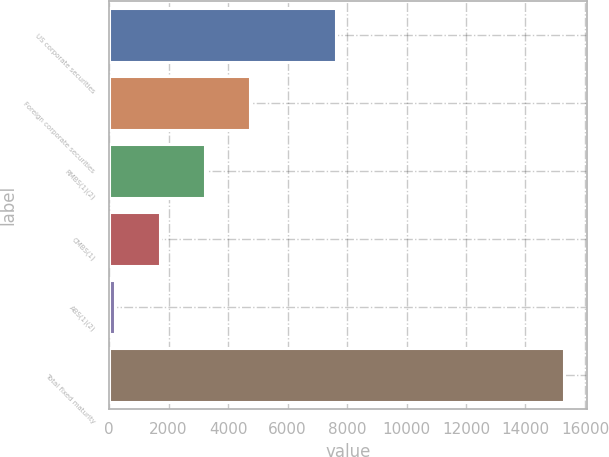Convert chart. <chart><loc_0><loc_0><loc_500><loc_500><bar_chart><fcel>US corporate securities<fcel>Foreign corporate securities<fcel>RMBS(1)(2)<fcel>CMBS(1)<fcel>ABS(1)(2)<fcel>Total fixed maturity<nl><fcel>7633<fcel>4725.6<fcel>3216.4<fcel>1707.2<fcel>198<fcel>15290<nl></chart> 